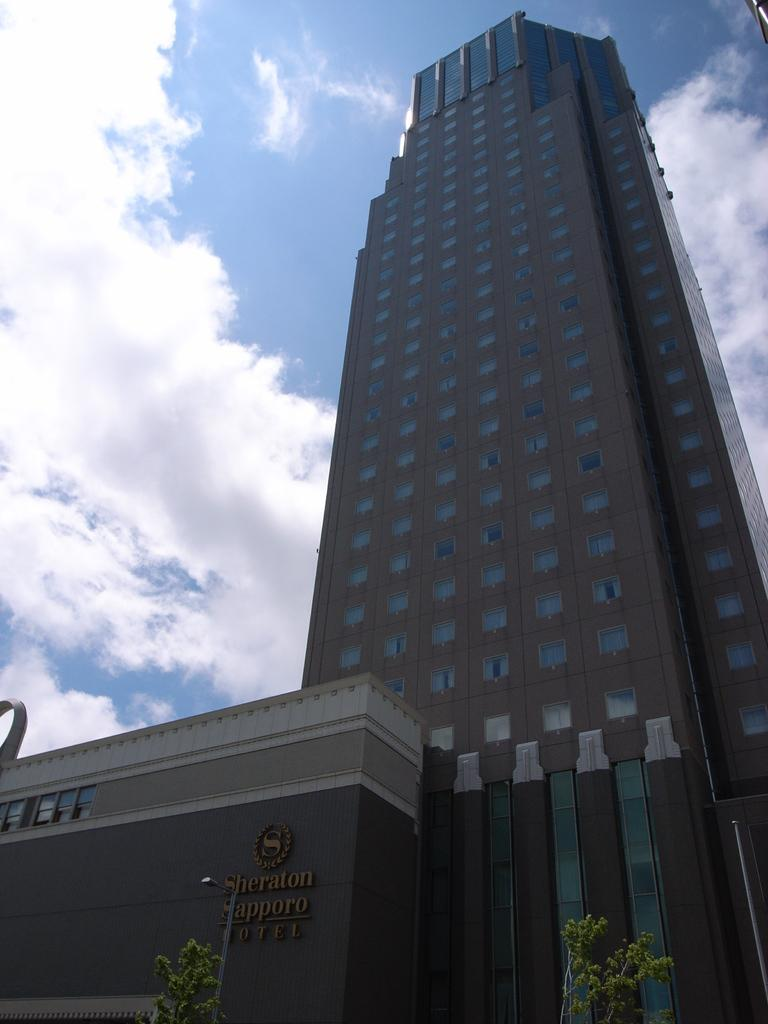What is the main structure in the image? There is a building in the image. What is located in front of the building? There are trees in front of the building. What can be seen in the background of the image? There are clouds visible in the background of the image. How many children are playing with a basket in the image? There are no children or baskets present in the image. What type of sign is hanging on the building in the image? There is no sign visible on the building in the image. 